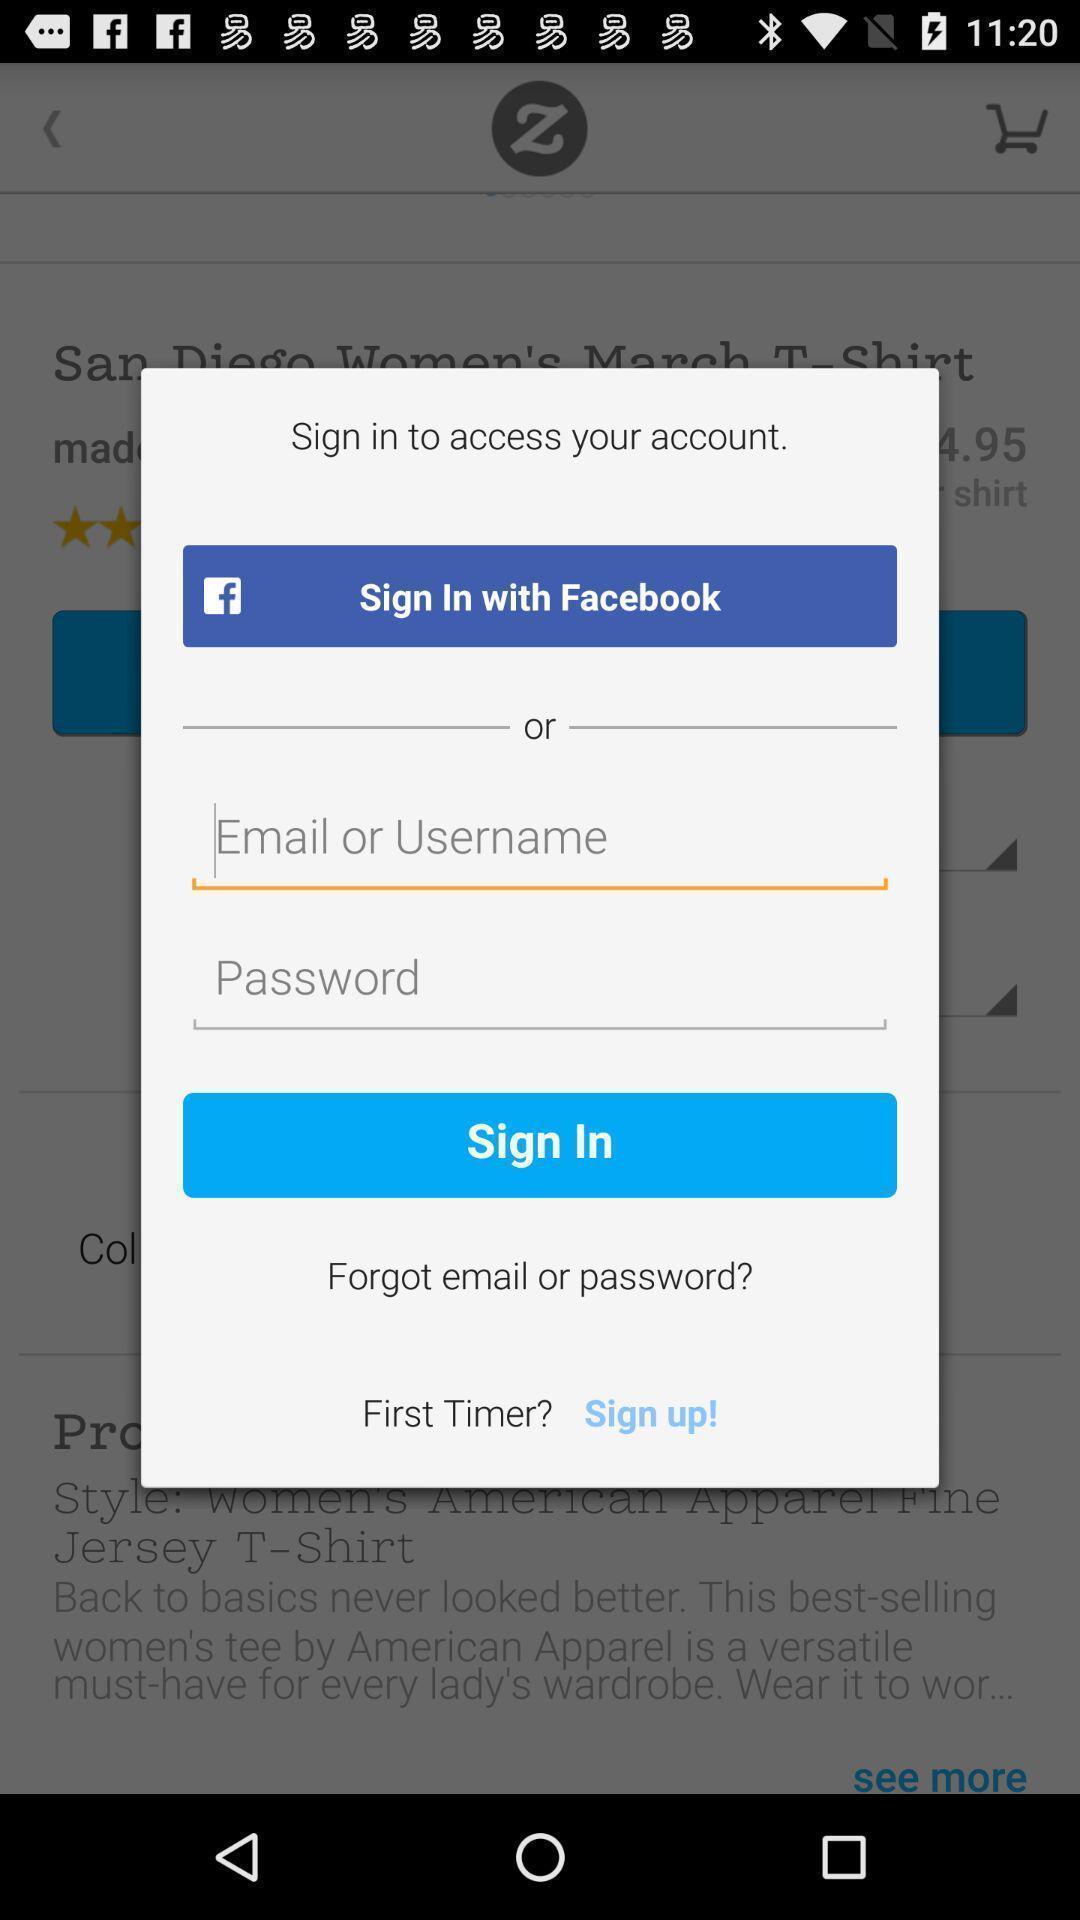What can you discern from this picture? Pop-up showing sign in page. 